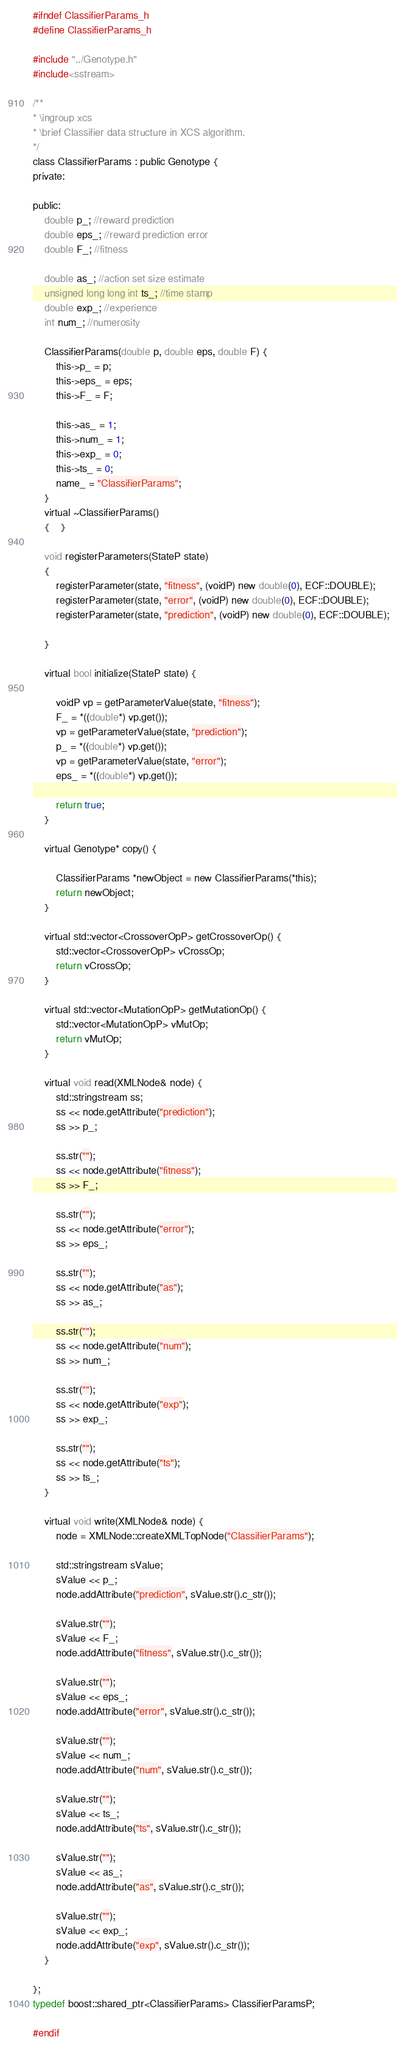<code> <loc_0><loc_0><loc_500><loc_500><_C_>#ifndef ClassifierParams_h
#define ClassifierParams_h

#include "../Genotype.h"
#include<sstream>

/**
* \ingroup xcs
* \brief Classifier data structure in XCS algorithm.
*/
class ClassifierParams : public Genotype {
private:

public:
	double p_; //reward prediction
	double eps_; //reward prediction error
	double F_; //fitness
	
	double as_; //action set size estimate
	unsigned long long int ts_; //time stamp
	double exp_; //experience
	int num_; //numerosity

	ClassifierParams(double p, double eps, double F) {	
		this->p_ = p;
		this->eps_ = eps;
		this->F_ = F;

		this->as_ = 1;
		this->num_ = 1;
		this->exp_ = 0;
		this->ts_ = 0;
		name_ = "ClassifierParams";
	}
	virtual ~ClassifierParams()
	{	}

	void registerParameters(StateP state)
	{
		registerParameter(state, "fitness", (voidP) new double(0), ECF::DOUBLE);
		registerParameter(state, "error", (voidP) new double(0), ECF::DOUBLE);
		registerParameter(state, "prediction", (voidP) new double(0), ECF::DOUBLE);

	}

	virtual bool initialize(StateP state) {
		
		voidP vp = getParameterValue(state, "fitness");
		F_ = *((double*) vp.get());
		vp = getParameterValue(state, "prediction");
		p_ = *((double*) vp.get());
		vp = getParameterValue(state, "error");
		eps_ = *((double*) vp.get());
		
		return true;
	}

	virtual Genotype* copy() {
		
		ClassifierParams *newObject = new ClassifierParams(*this);
		return newObject;
	}

	virtual std::vector<CrossoverOpP> getCrossoverOp() {
		std::vector<CrossoverOpP> vCrossOp;
		return vCrossOp;
	}

	virtual std::vector<MutationOpP> getMutationOp() {
		std::vector<MutationOpP> vMutOp;
		return vMutOp;
	}	

	virtual void read(XMLNode& node) {
		std::stringstream ss;
		ss << node.getAttribute("prediction");
		ss >> p_;
		
		ss.str("");
		ss << node.getAttribute("fitness");
		ss >> F_;

		ss.str("");
		ss << node.getAttribute("error");
		ss >> eps_;

		ss.str("");
		ss << node.getAttribute("as");
		ss >> as_;

		ss.str("");
		ss << node.getAttribute("num");
		ss >> num_;

		ss.str("");
		ss << node.getAttribute("exp");
		ss >> exp_;

		ss.str("");
		ss << node.getAttribute("ts");
		ss >> ts_;
	}

	virtual void write(XMLNode& node) {
		node = XMLNode::createXMLTopNode("ClassifierParams");
		
		std::stringstream sValue;
		sValue << p_;
		node.addAttribute("prediction", sValue.str().c_str());

		sValue.str("");
		sValue << F_;
		node.addAttribute("fitness", sValue.str().c_str());

		sValue.str("");
		sValue << eps_;
		node.addAttribute("error", sValue.str().c_str());

		sValue.str("");
		sValue << num_;
		node.addAttribute("num", sValue.str().c_str());

		sValue.str("");
		sValue << ts_;
		node.addAttribute("ts", sValue.str().c_str());

		sValue.str("");
		sValue << as_;
		node.addAttribute("as", sValue.str().c_str());

		sValue.str("");
		sValue << exp_;
		node.addAttribute("exp", sValue.str().c_str());
	}

};
typedef boost::shared_ptr<ClassifierParams> ClassifierParamsP;

#endif </code> 